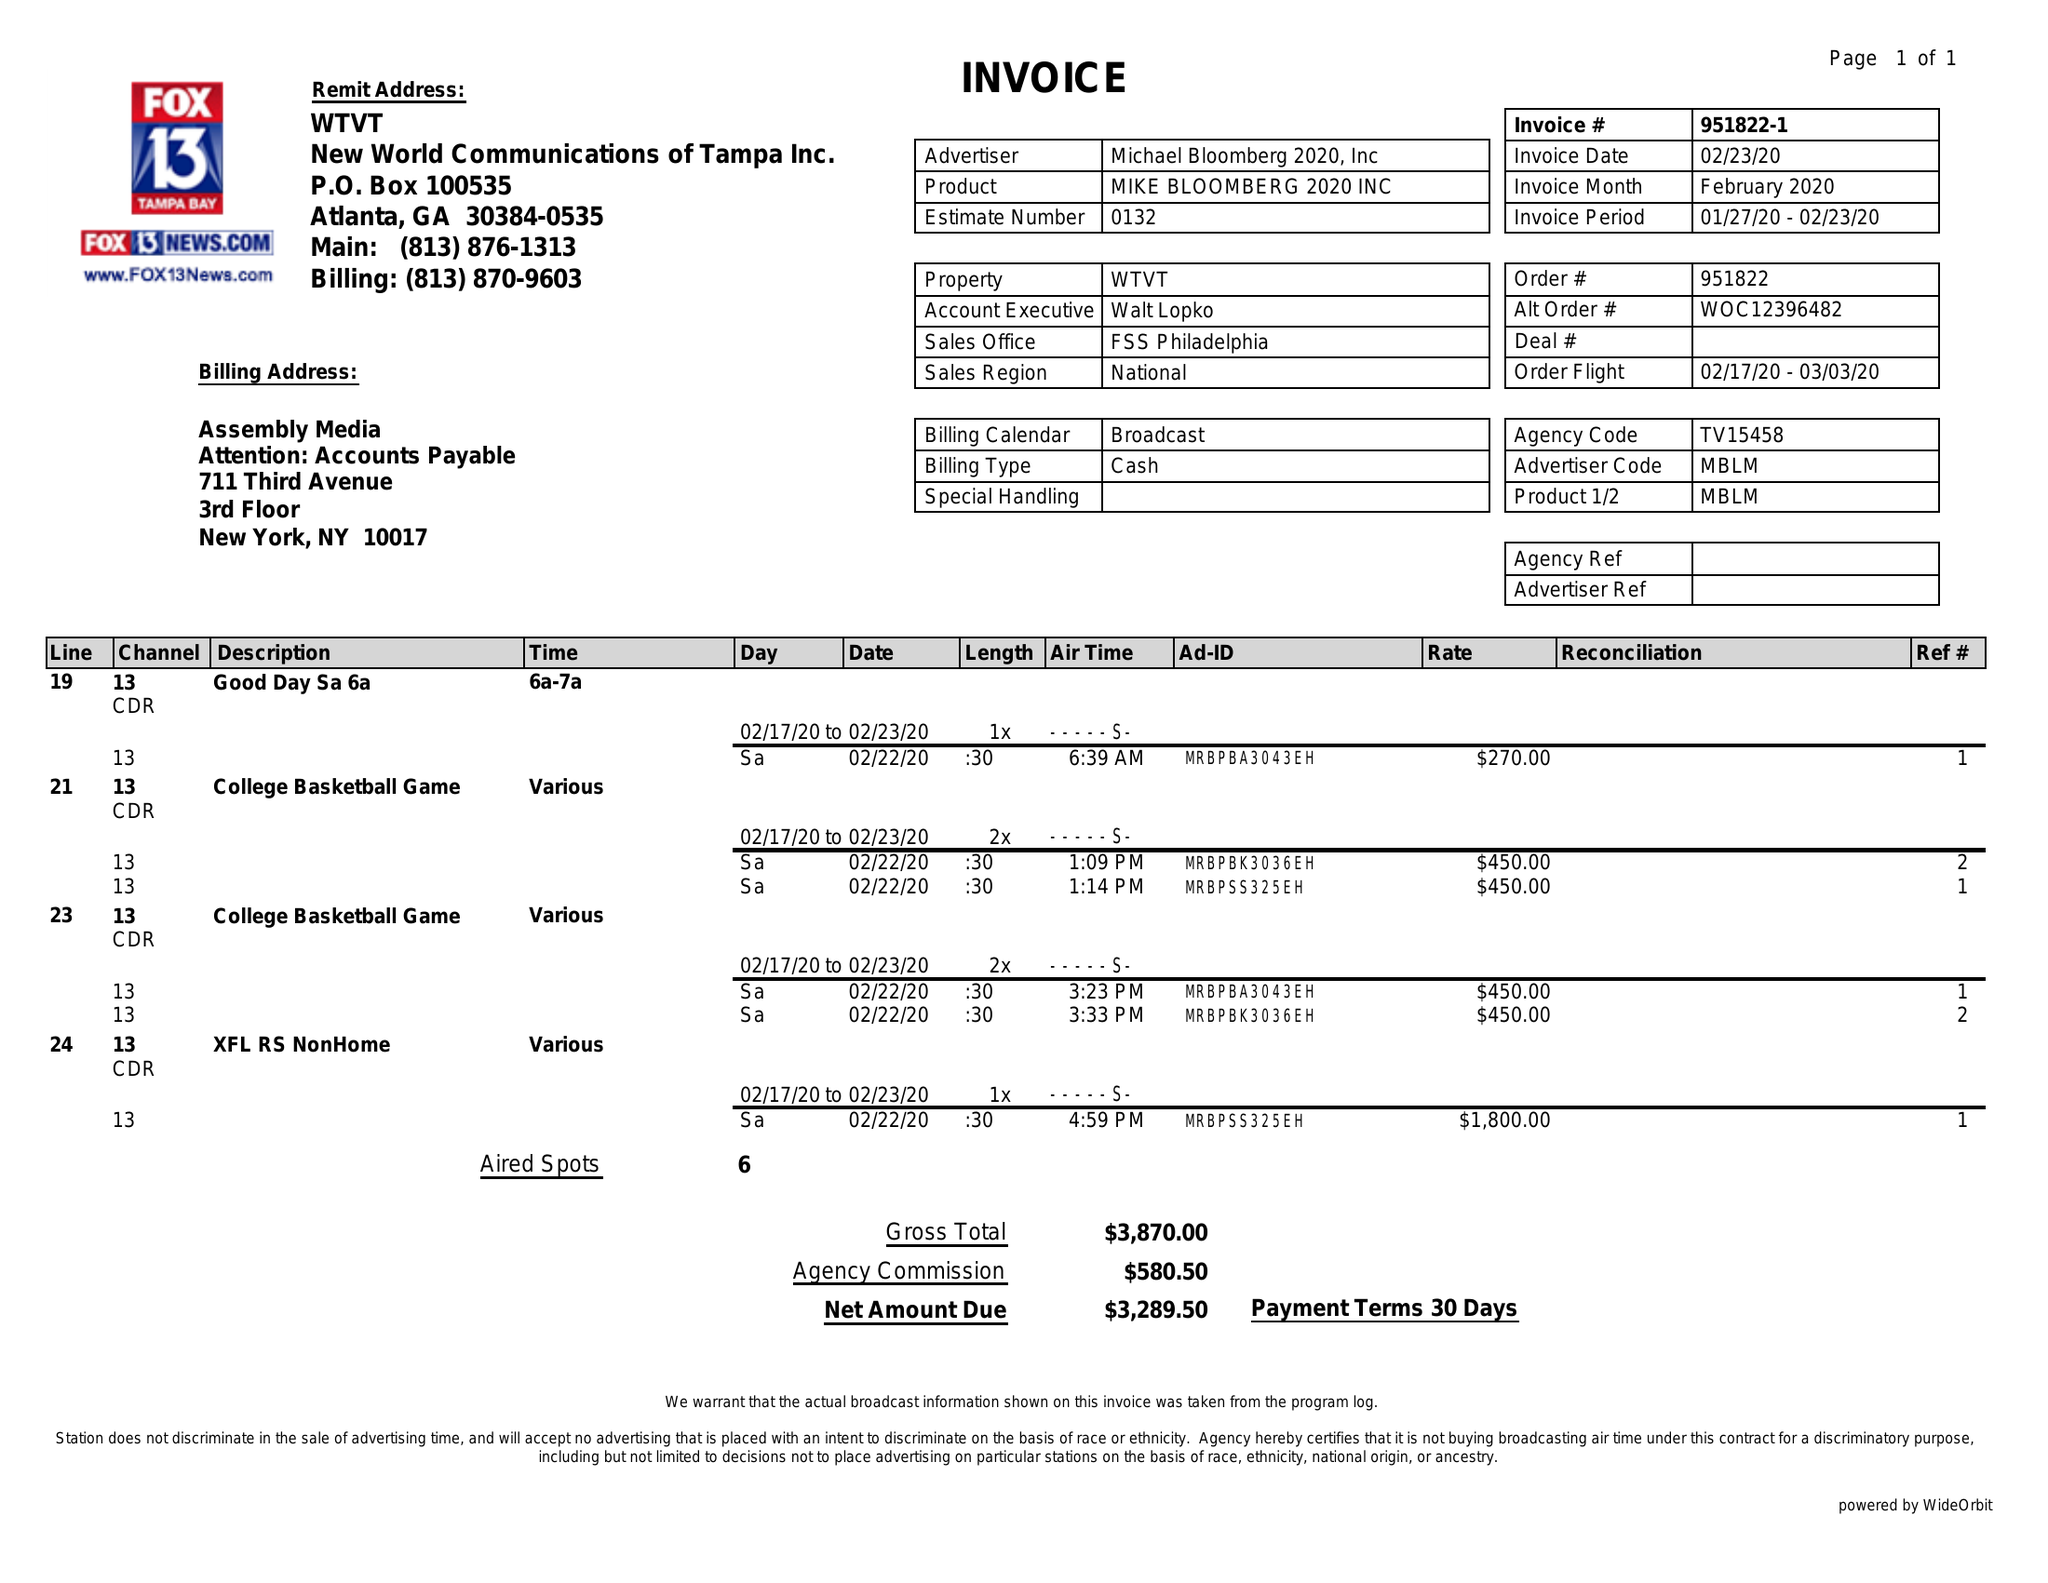What is the value for the flight_to?
Answer the question using a single word or phrase. 03/03/20 